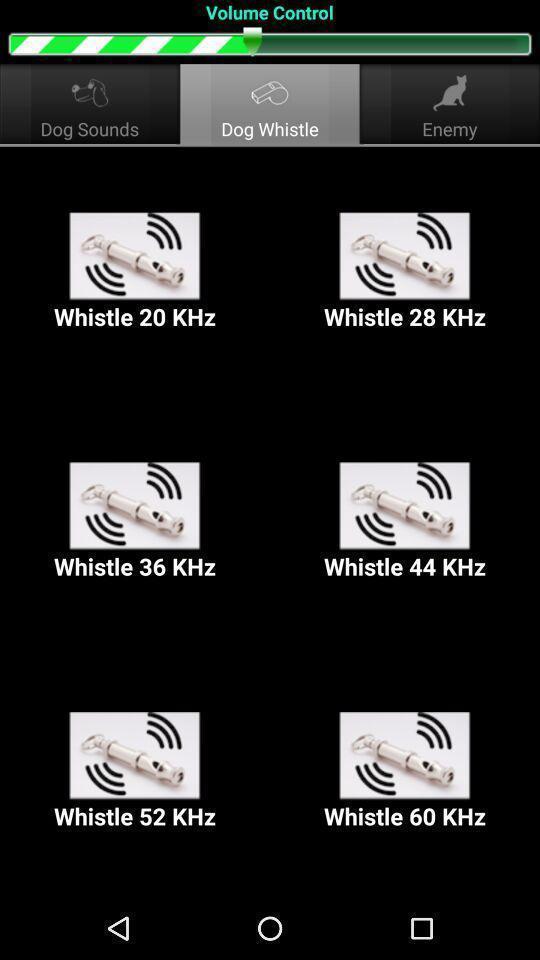Provide a description of this screenshot. Screen showing different whistles in a volume control. 